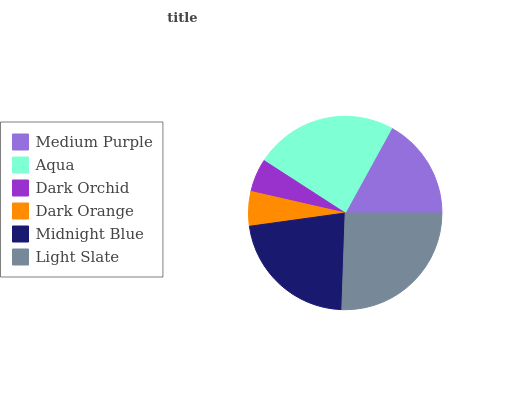Is Dark Orchid the minimum?
Answer yes or no. Yes. Is Light Slate the maximum?
Answer yes or no. Yes. Is Aqua the minimum?
Answer yes or no. No. Is Aqua the maximum?
Answer yes or no. No. Is Aqua greater than Medium Purple?
Answer yes or no. Yes. Is Medium Purple less than Aqua?
Answer yes or no. Yes. Is Medium Purple greater than Aqua?
Answer yes or no. No. Is Aqua less than Medium Purple?
Answer yes or no. No. Is Midnight Blue the high median?
Answer yes or no. Yes. Is Medium Purple the low median?
Answer yes or no. Yes. Is Aqua the high median?
Answer yes or no. No. Is Light Slate the low median?
Answer yes or no. No. 